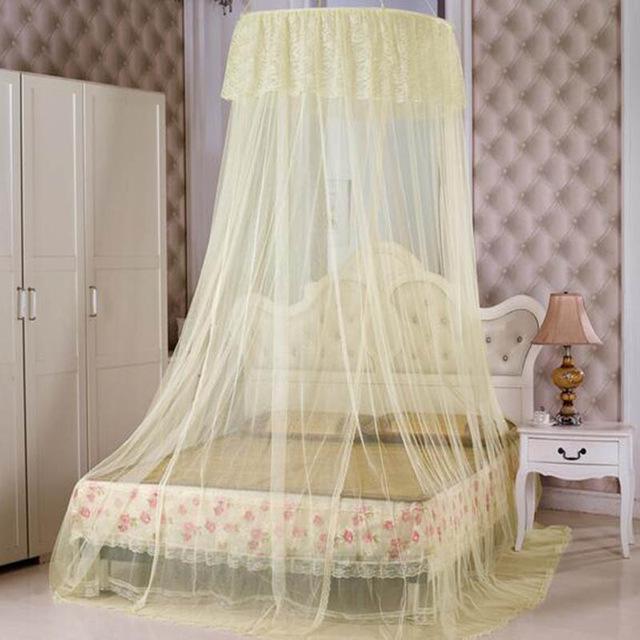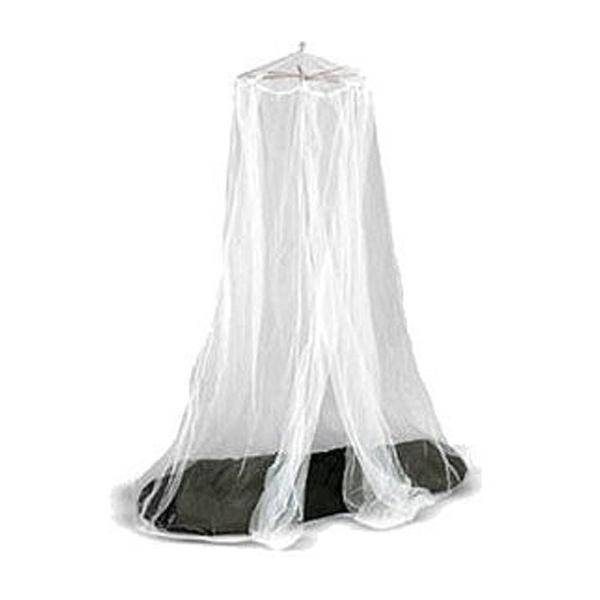The first image is the image on the left, the second image is the image on the right. Considering the images on both sides, is "Exactly one net is white." valid? Answer yes or no. Yes. The first image is the image on the left, the second image is the image on the right. Considering the images on both sides, is "None of these bed canopies are presently covering a regular, rectangular bed." valid? Answer yes or no. No. 